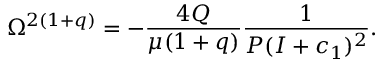Convert formula to latex. <formula><loc_0><loc_0><loc_500><loc_500>\Omega ^ { 2 ( 1 + q ) } = - \frac { 4 Q } { \mu ( 1 + q ) } \frac { 1 } { P ( I + c _ { 1 } ) ^ { 2 } } .</formula> 